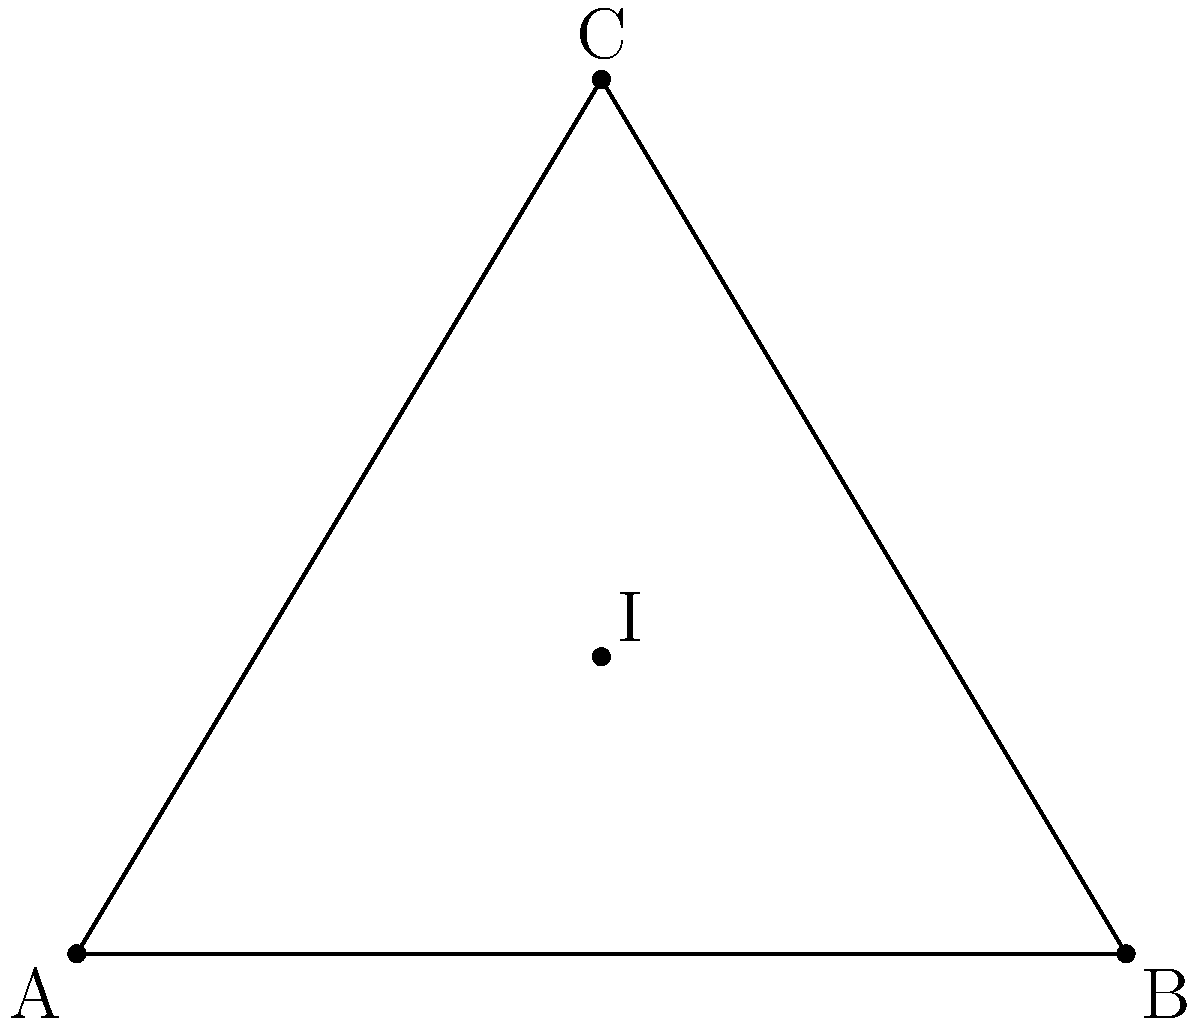In a triangular safe zone represented by triangle ABC, you need to find the most secure location. This point should be equidistant from all sides of the triangle. If AB = 6 units, BC ≈ 5.83 units, and AC ≈ 5.83 units, what is the distance from this safest point to any side of the triangle? 1. The safest point in a triangle, equidistant from all sides, is the incenter (I).

2. To find the distance from I to any side, we need to calculate the inradius (r).

3. The formula for the inradius is: 
   $$r = \frac{A}{s}$$
   where A is the area of the triangle and s is the semi-perimeter.

4. Calculate the semi-perimeter:
   $$s = \frac{a + b + c}{2} = \frac{6 + 5.83 + 5.83}{2} ≈ 8.83$$

5. Calculate the area using Heron's formula:
   $$A = \sqrt{s(s-a)(s-b)(s-c)}$$
   $$A = \sqrt{8.83(8.83-6)(8.83-5.83)(8.83-5.83)} ≈ 14.99$$

6. Now we can calculate the inradius:
   $$r = \frac{A}{s} = \frac{14.99}{8.83} ≈ 1.70$$

7. Therefore, the distance from the incenter to any side of the triangle is approximately 1.70 units.
Answer: 1.70 units 